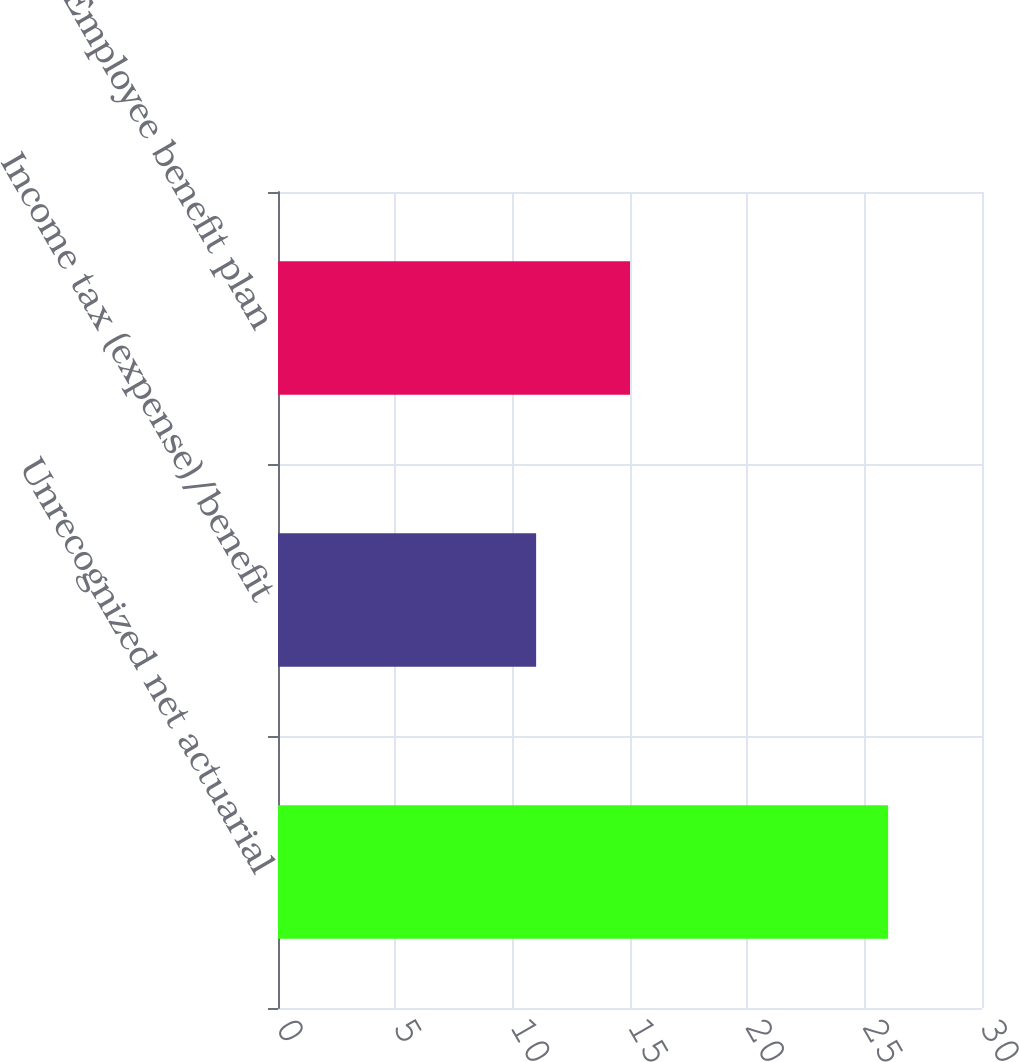Convert chart to OTSL. <chart><loc_0><loc_0><loc_500><loc_500><bar_chart><fcel>Unrecognized net actuarial<fcel>Income tax (expense)/benefit<fcel>Employee benefit plan<nl><fcel>26<fcel>11<fcel>15<nl></chart> 